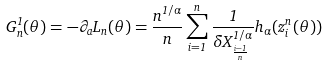<formula> <loc_0><loc_0><loc_500><loc_500>G _ { n } ^ { 1 } ( \theta ) = - \partial _ { a } L _ { n } ( \theta ) = \frac { n ^ { 1 / \alpha } } { n } \sum _ { i = 1 } ^ { n } \frac { 1 } { \delta X _ { \frac { i - 1 } { n } } ^ { 1 / \alpha } } h _ { \alpha } ( z ^ { n } _ { i } ( \theta ) )</formula> 